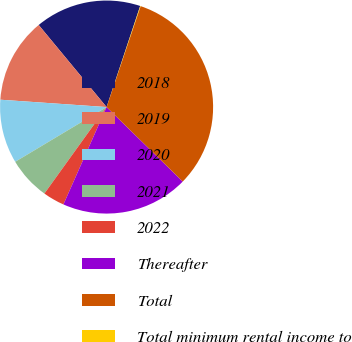Convert chart to OTSL. <chart><loc_0><loc_0><loc_500><loc_500><pie_chart><fcel>2018<fcel>2019<fcel>2020<fcel>2021<fcel>2022<fcel>Thereafter<fcel>Total<fcel>Total minimum rental income to<nl><fcel>16.11%<fcel>12.9%<fcel>9.69%<fcel>6.49%<fcel>3.28%<fcel>19.32%<fcel>32.15%<fcel>0.07%<nl></chart> 